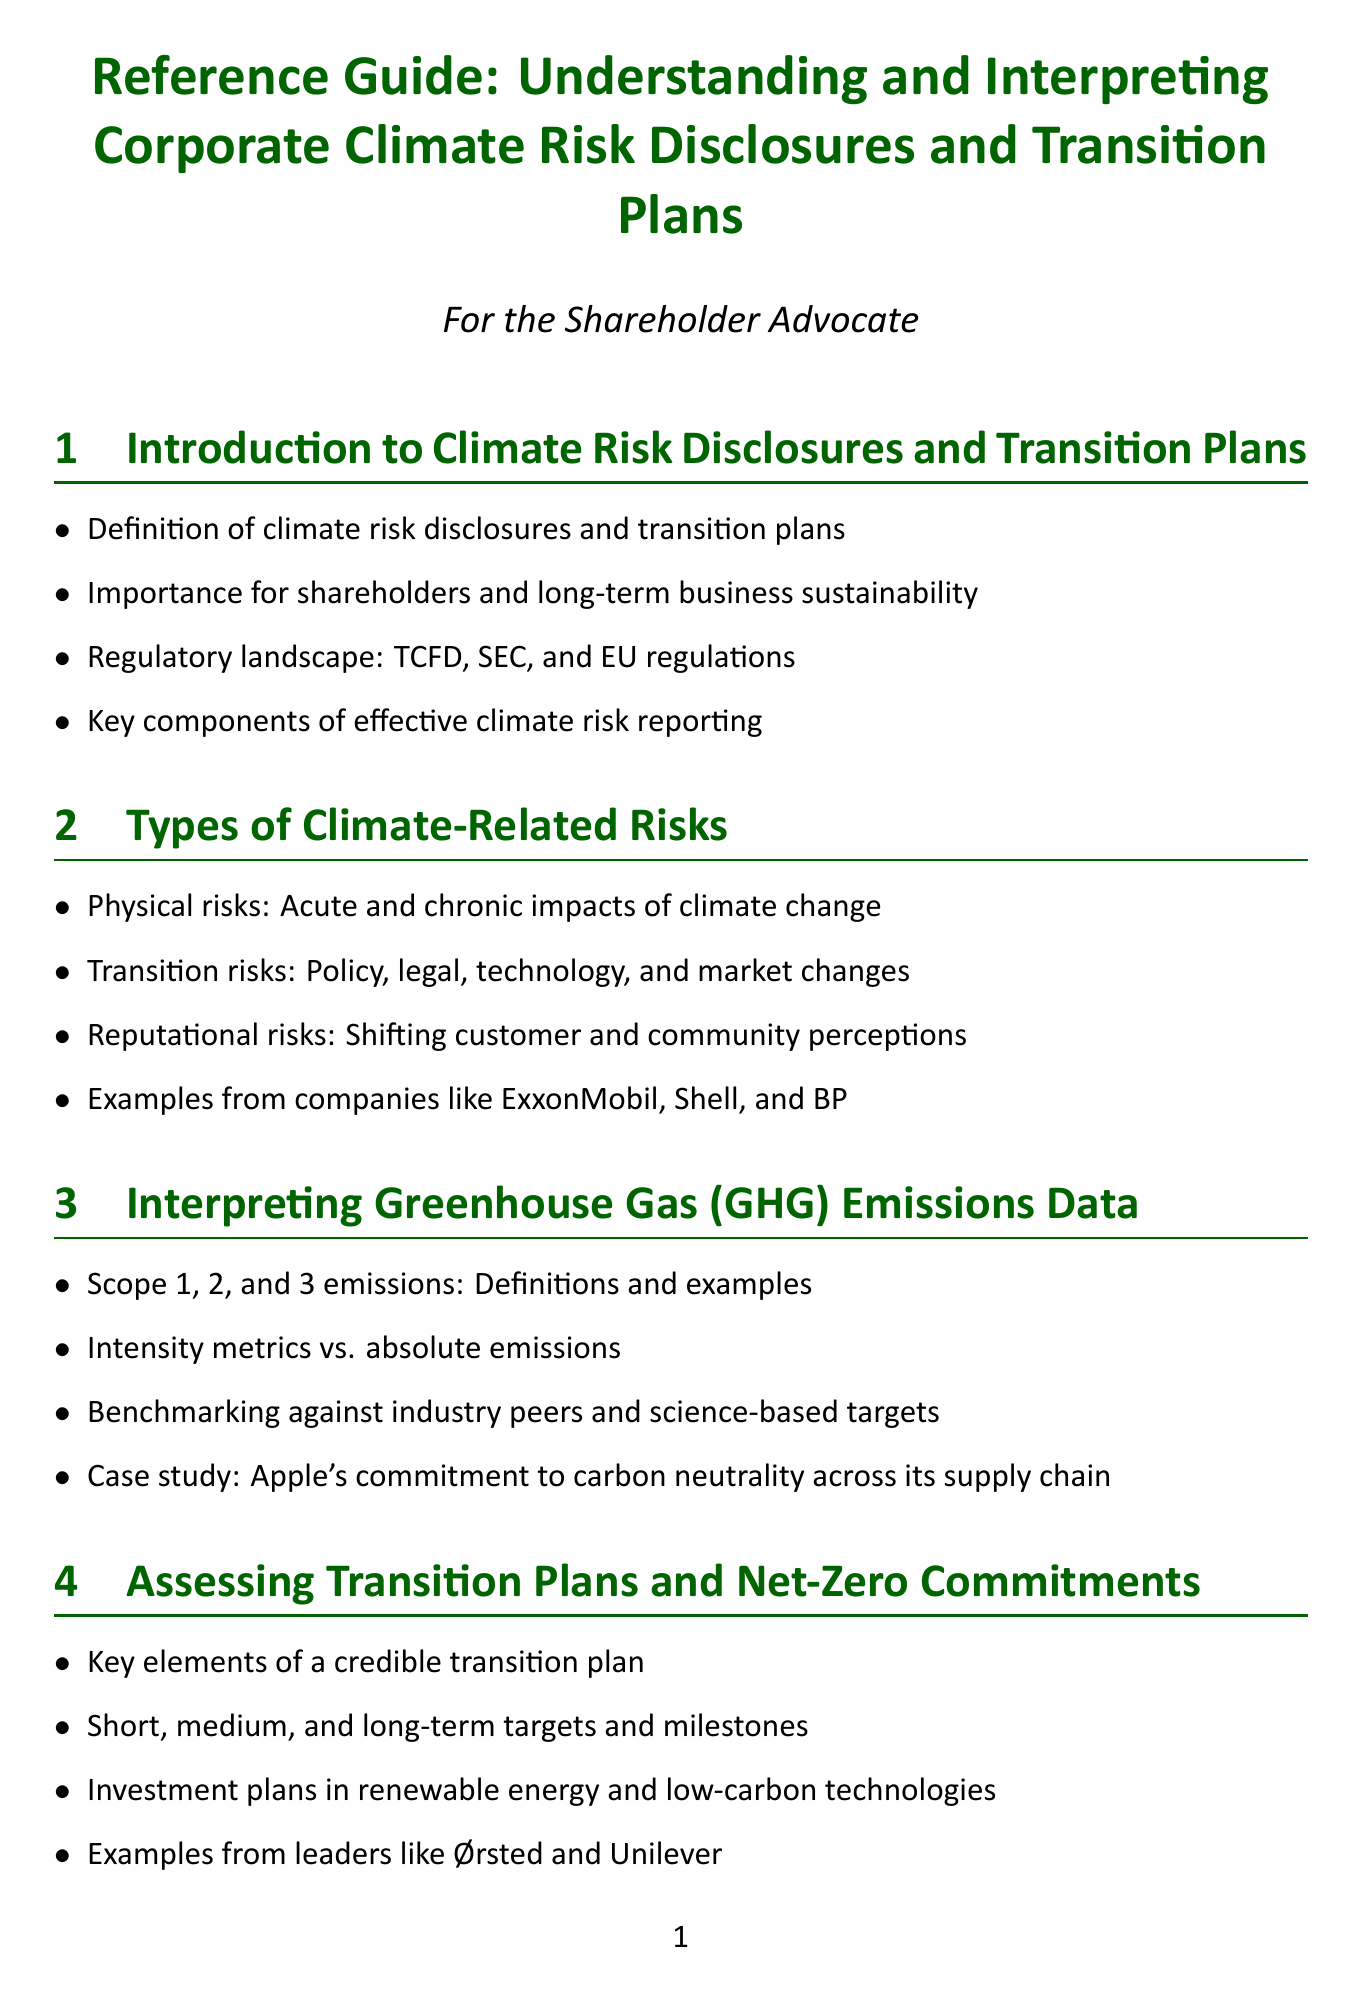what is the focus of the introduction section? The introduction section discusses definitions, importance for shareholders, regulatory landscape, and key components of effective climate risk reporting.
Answer: climate risk disclosures and transition plans which regulations are mentioned in the introduction? The introduction lists important regulations that affect climate risk disclosures and transition plans, specifically TCFD, SEC, and EU regulations.
Answer: TCFD, SEC, and EU regulations what are the types of physical risks described? The document outlines specific types of climate-related risks, including acute and chronic impacts of climate change as physical risks.
Answer: acute and chronic impacts of climate change who is cited as an example of effective emissions management in the GHG emissions data section? The GHG emissions data section includes a case study that highlights a company's commitment to carbon neutrality across its supply chain as an example.
Answer: Apple what should a credible transition plan include? The section on assessing transition plans outlines the necessary elements that are considered key to a credible transition plan.
Answer: key elements of a credible transition plan which organization is mentioned in relation to climate risk assessment methodology? The financial implications section references a particular organization's methodology for climate risk assessment as a case study.
Answer: BlackRock what is the significance of Scope 3 emissions management? The importance of addressing upstream and downstream emissions is highlighted as part of effective supply chain management related to climate change.
Answer: importance of addressing upstream and downstream emissions which companies are noted for their renewable energy commitments? The document mentions specific companies that are recognized for their strong commitments and investments in renewable energy.
Answer: Google and Walmart what are the accusations discussed in the red flags section? The red flags section talks about the allegations made against companies regarding their credibility in climate disclosures, particularly accusations of greenwashing.
Answer: greenwashing allegations 